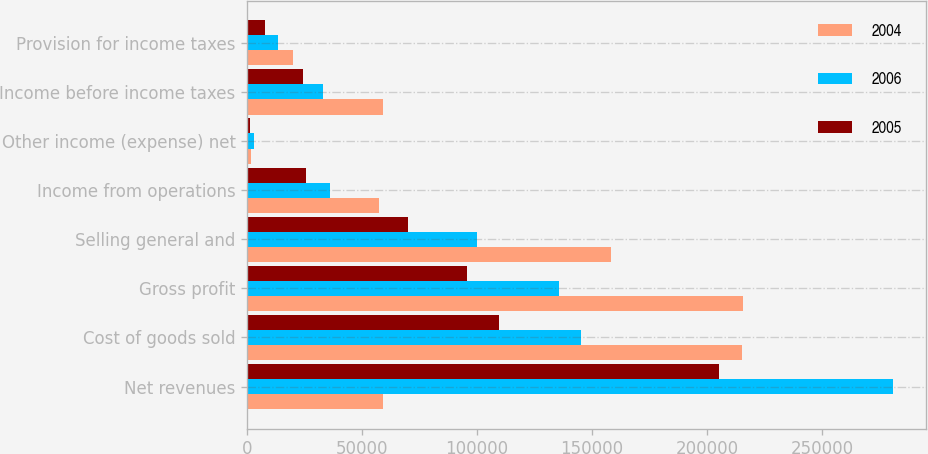<chart> <loc_0><loc_0><loc_500><loc_500><stacked_bar_chart><ecel><fcel>Net revenues<fcel>Cost of goods sold<fcel>Gross profit<fcel>Selling general and<fcel>Income from operations<fcel>Other income (expense) net<fcel>Income before income taxes<fcel>Provision for income taxes<nl><fcel>2004<fcel>59087<fcel>215089<fcel>215600<fcel>158323<fcel>57277<fcel>1810<fcel>59087<fcel>20108<nl><fcel>2006<fcel>281053<fcel>145203<fcel>135850<fcel>99961<fcel>35889<fcel>2915<fcel>32974<fcel>13255<nl><fcel>2005<fcel>205181<fcel>109748<fcel>95433<fcel>70053<fcel>25380<fcel>1284<fcel>24096<fcel>7774<nl></chart> 